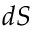<formula> <loc_0><loc_0><loc_500><loc_500>d S</formula> 